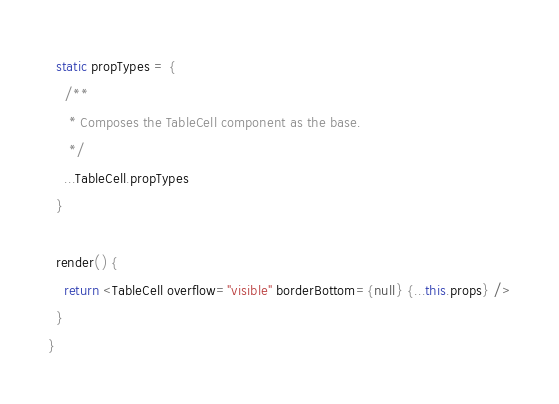Convert code to text. <code><loc_0><loc_0><loc_500><loc_500><_JavaScript_>  static propTypes = {
    /**
     * Composes the TableCell component as the base.
     */
    ...TableCell.propTypes
  }

  render() {
    return <TableCell overflow="visible" borderBottom={null} {...this.props} />
  }
}
</code> 